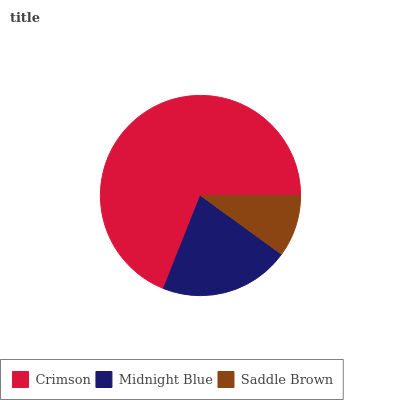Is Saddle Brown the minimum?
Answer yes or no. Yes. Is Crimson the maximum?
Answer yes or no. Yes. Is Midnight Blue the minimum?
Answer yes or no. No. Is Midnight Blue the maximum?
Answer yes or no. No. Is Crimson greater than Midnight Blue?
Answer yes or no. Yes. Is Midnight Blue less than Crimson?
Answer yes or no. Yes. Is Midnight Blue greater than Crimson?
Answer yes or no. No. Is Crimson less than Midnight Blue?
Answer yes or no. No. Is Midnight Blue the high median?
Answer yes or no. Yes. Is Midnight Blue the low median?
Answer yes or no. Yes. Is Crimson the high median?
Answer yes or no. No. Is Saddle Brown the low median?
Answer yes or no. No. 